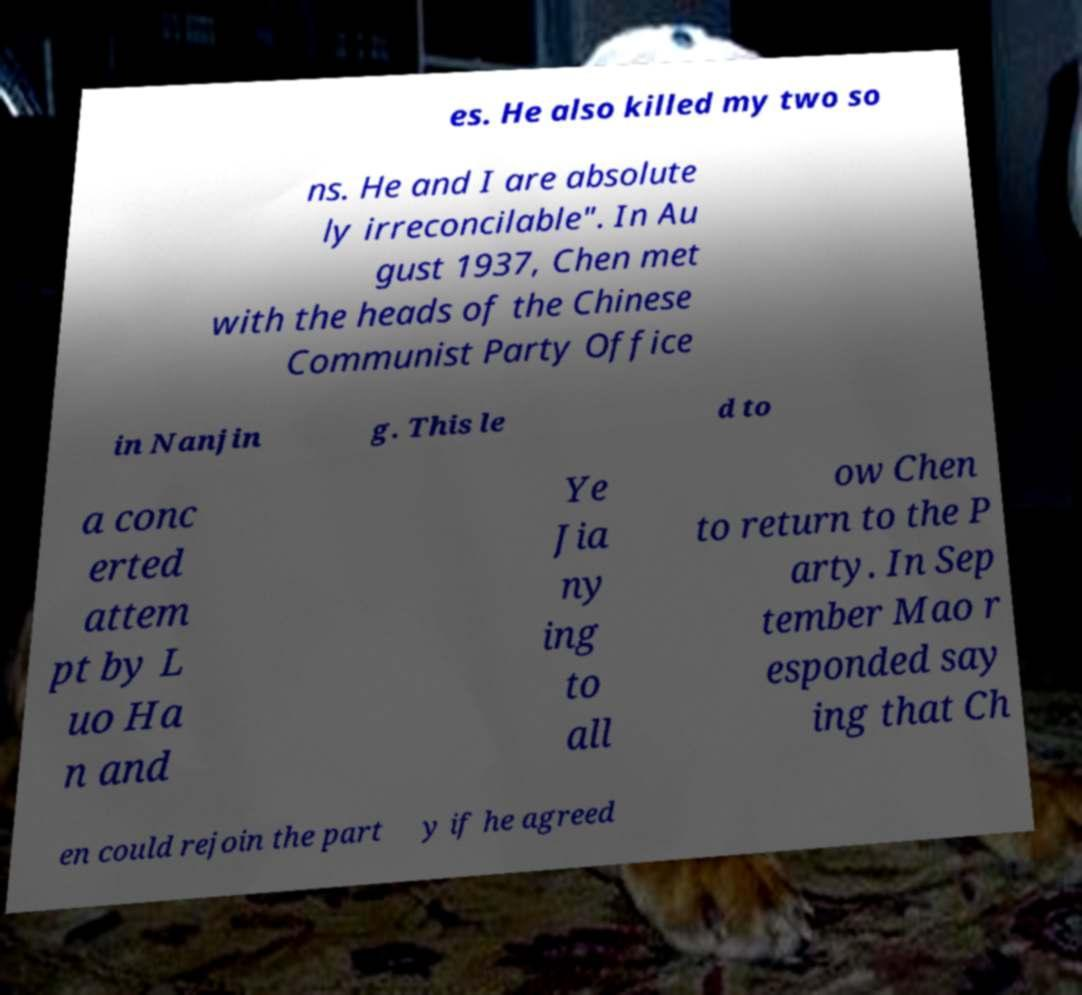Can you accurately transcribe the text from the provided image for me? es. He also killed my two so ns. He and I are absolute ly irreconcilable". In Au gust 1937, Chen met with the heads of the Chinese Communist Party Office in Nanjin g. This le d to a conc erted attem pt by L uo Ha n and Ye Jia ny ing to all ow Chen to return to the P arty. In Sep tember Mao r esponded say ing that Ch en could rejoin the part y if he agreed 